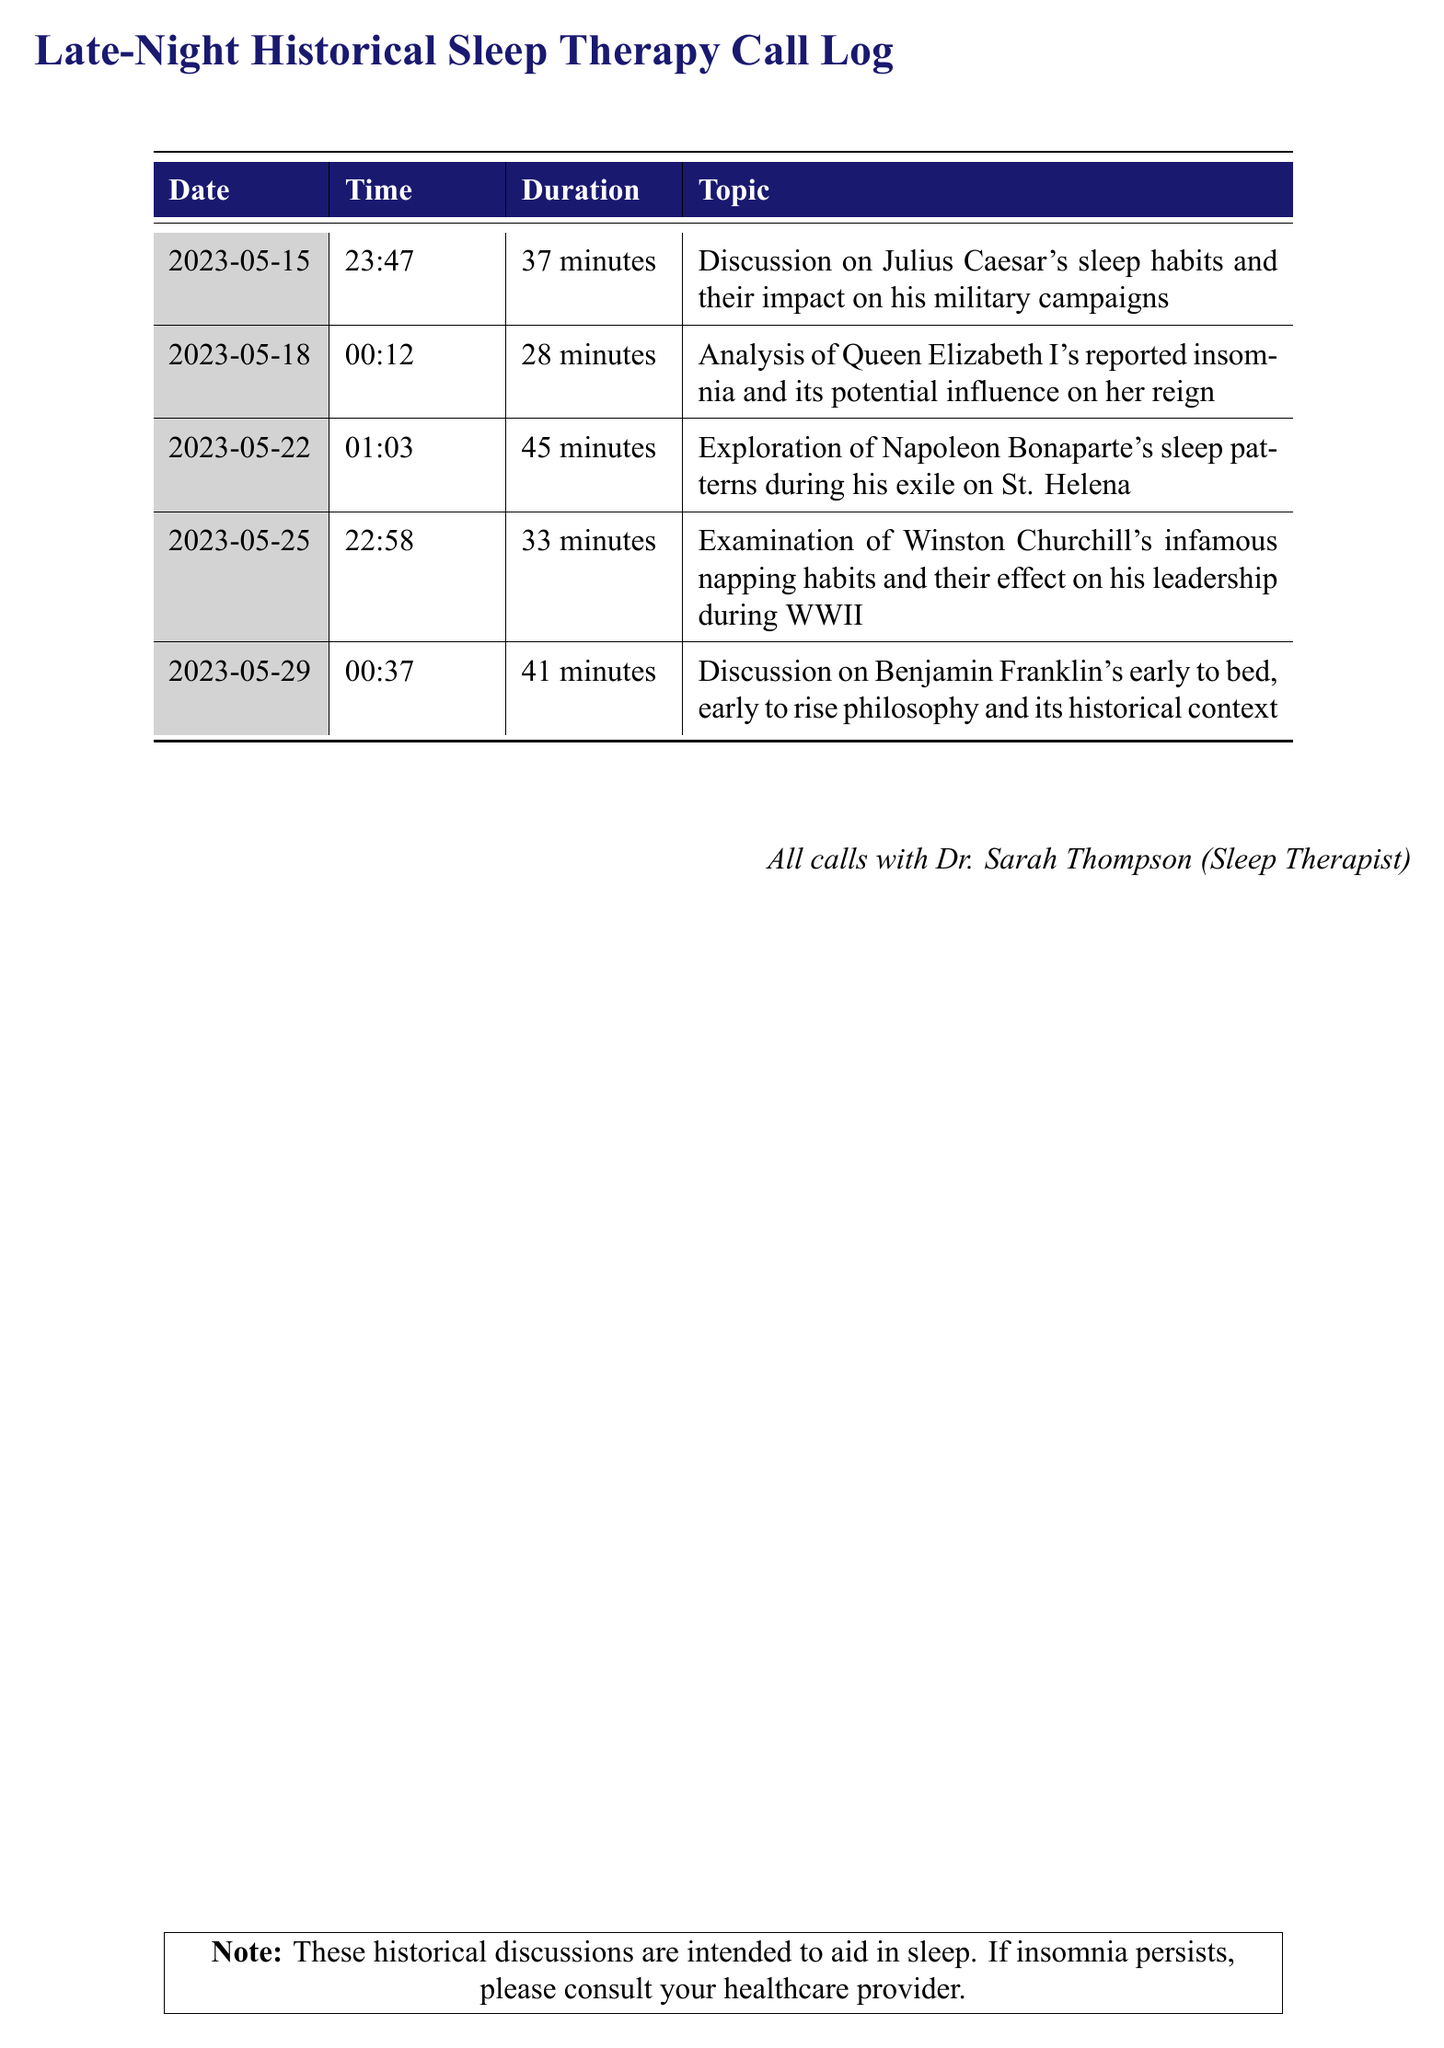What date was the call regarding Julius Caesar? The date for the discussion on Julius Caesar's sleep habits is listed in the call log.
Answer: 2023-05-15 What was the duration of the call about Napoleon Bonaparte? The duration for the call discussing Napoleon Bonaparte's sleep patterns is specifically mentioned in the log.
Answer: 45 minutes Who is the sleep therapist involved in these discussions? The call log states that all calls were with Dr. Sarah Thompson.
Answer: Dr. Sarah Thompson What topic was discussed on May 29? The log provides the specific topic discussed on each date, including May 29.
Answer: Benjamin Franklin's early to bed, early to rise philosophy How many calls were made in total? The total number of calls can be counted from the entries listed in the call log.
Answer: 5 calls Which historical figure's insomnia was analyzed for its influence on their reign? The log records a specific analysis of a historical figure related to insomnia that influenced their reign.
Answer: Queen Elizabeth I What was the earliest time a call occurred? The earliest time can be determined by identifying the times listed for each call in the log.
Answer: 00:12 Which historical figure is associated with napping habits during WWII? The call log explicitly mentions one historical figure in relation to napping habits and WWII.
Answer: Winston Churchill What color is used in the table header? The table header is designed with a specific color that can be identified by reviewing the visual aspect of the document.
Answer: midnight 